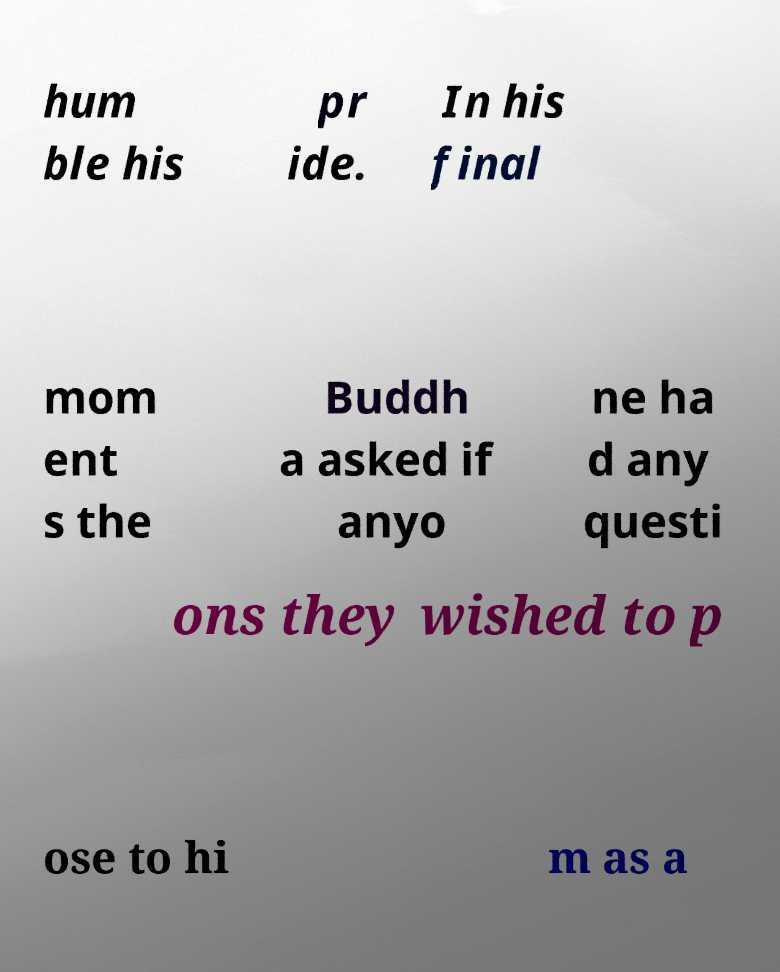For documentation purposes, I need the text within this image transcribed. Could you provide that? hum ble his pr ide. In his final mom ent s the Buddh a asked if anyo ne ha d any questi ons they wished to p ose to hi m as a 